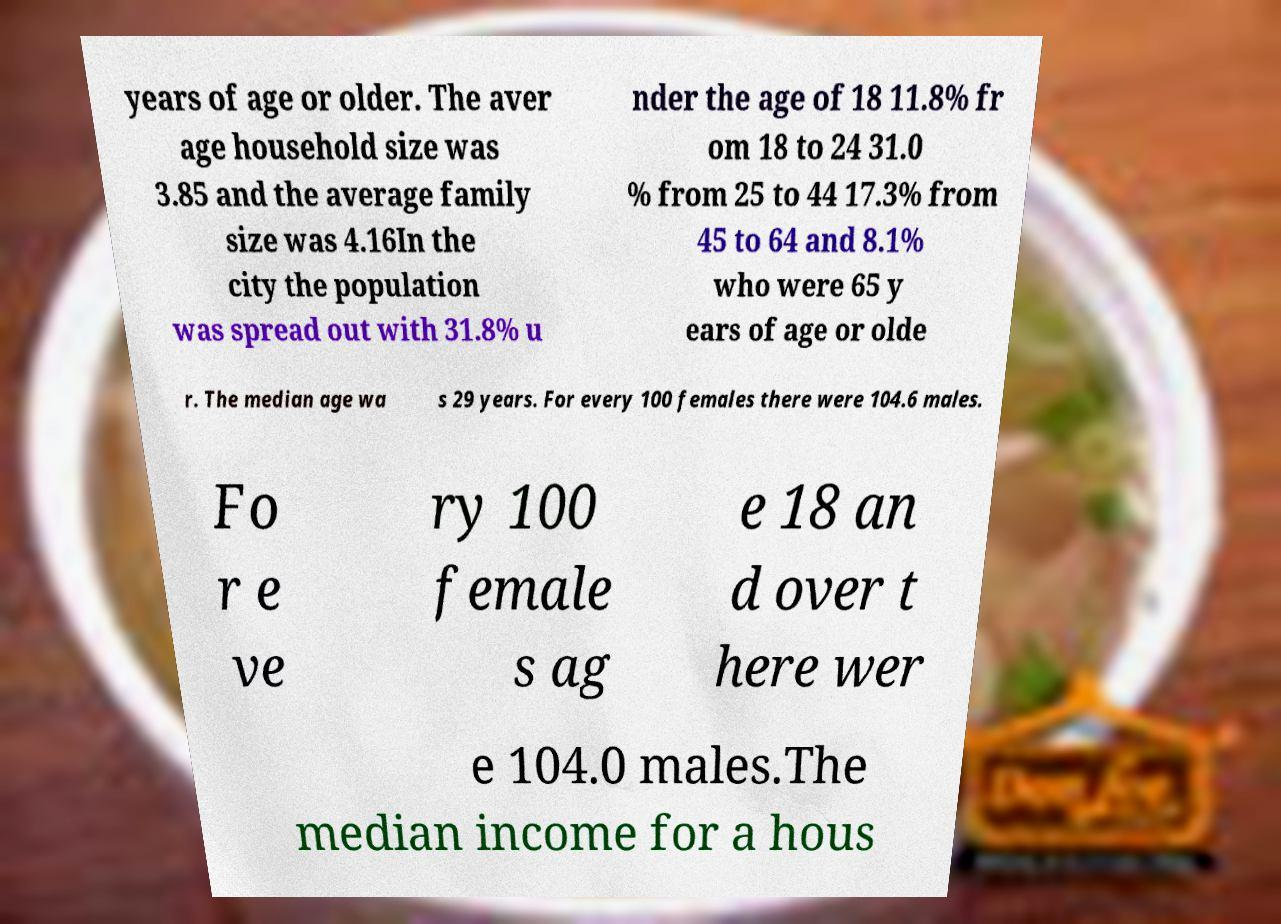Could you assist in decoding the text presented in this image and type it out clearly? years of age or older. The aver age household size was 3.85 and the average family size was 4.16In the city the population was spread out with 31.8% u nder the age of 18 11.8% fr om 18 to 24 31.0 % from 25 to 44 17.3% from 45 to 64 and 8.1% who were 65 y ears of age or olde r. The median age wa s 29 years. For every 100 females there were 104.6 males. Fo r e ve ry 100 female s ag e 18 an d over t here wer e 104.0 males.The median income for a hous 